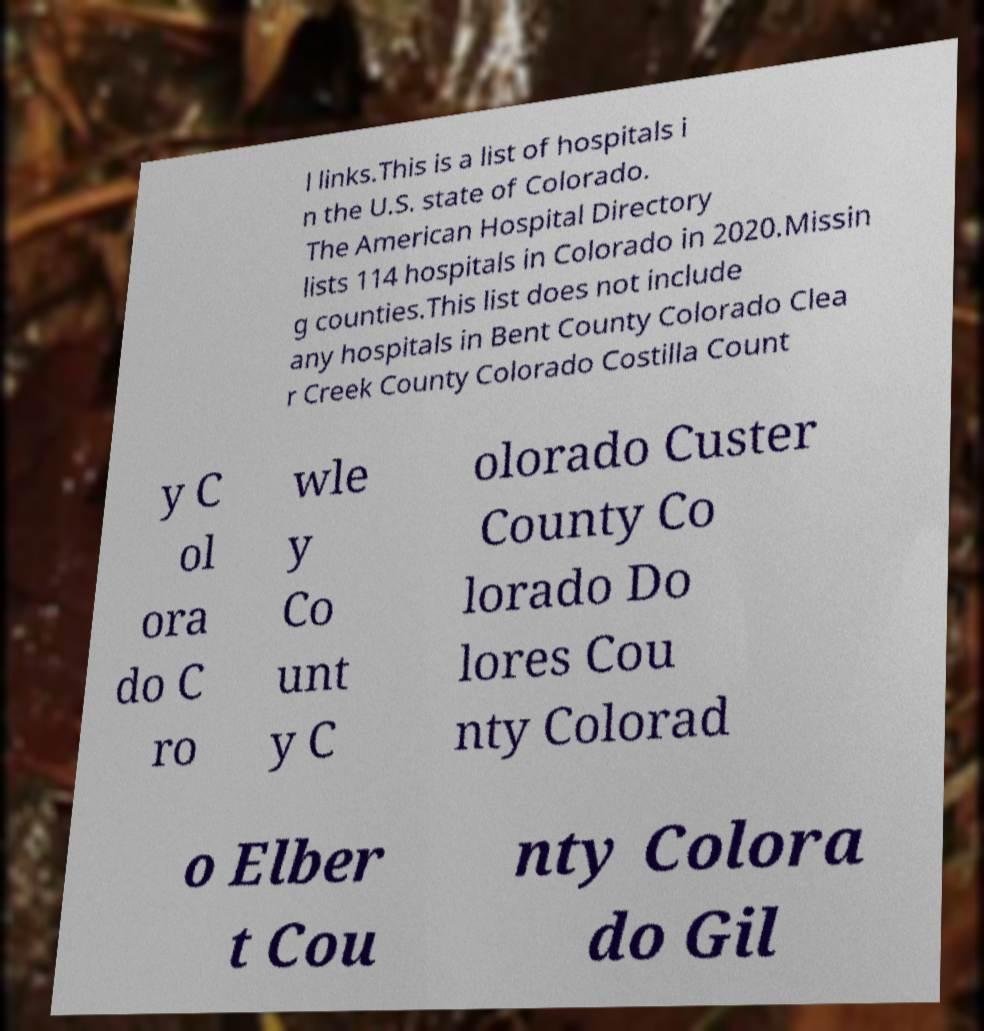Can you accurately transcribe the text from the provided image for me? l links.This is a list of hospitals i n the U.S. state of Colorado. The American Hospital Directory lists 114 hospitals in Colorado in 2020.Missin g counties.This list does not include any hospitals in Bent County Colorado Clea r Creek County Colorado Costilla Count y C ol ora do C ro wle y Co unt y C olorado Custer County Co lorado Do lores Cou nty Colorad o Elber t Cou nty Colora do Gil 